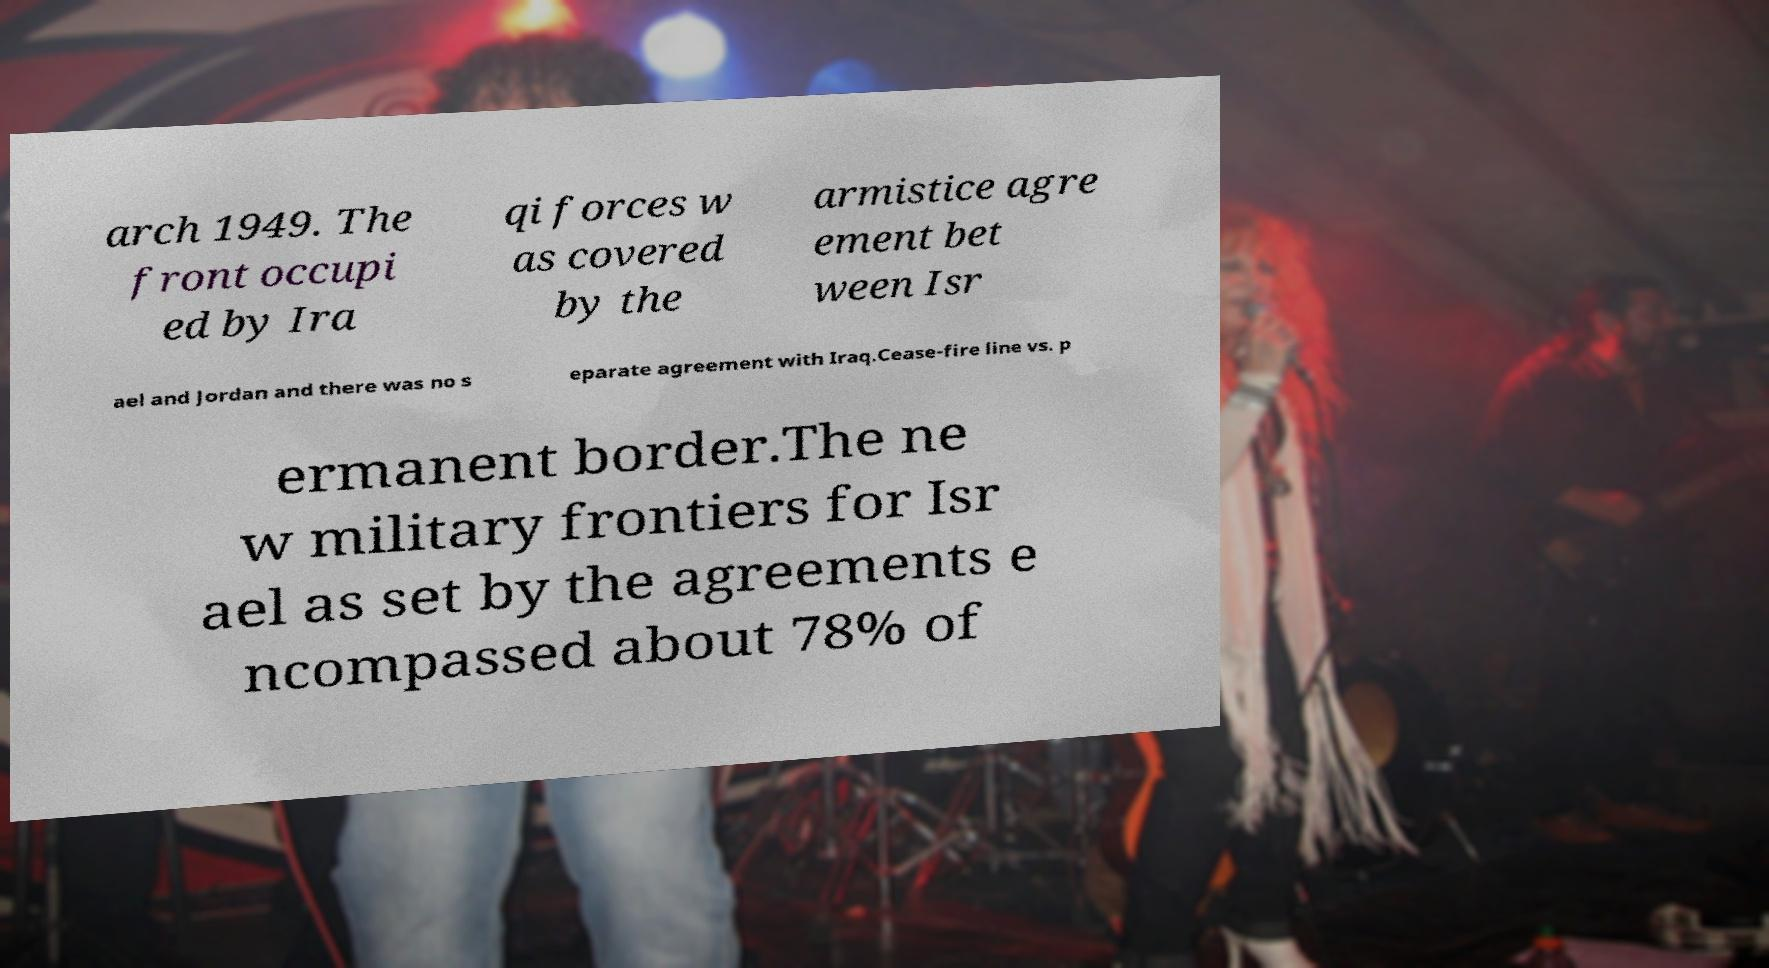Please identify and transcribe the text found in this image. arch 1949. The front occupi ed by Ira qi forces w as covered by the armistice agre ement bet ween Isr ael and Jordan and there was no s eparate agreement with Iraq.Cease-fire line vs. p ermanent border.The ne w military frontiers for Isr ael as set by the agreements e ncompassed about 78% of 